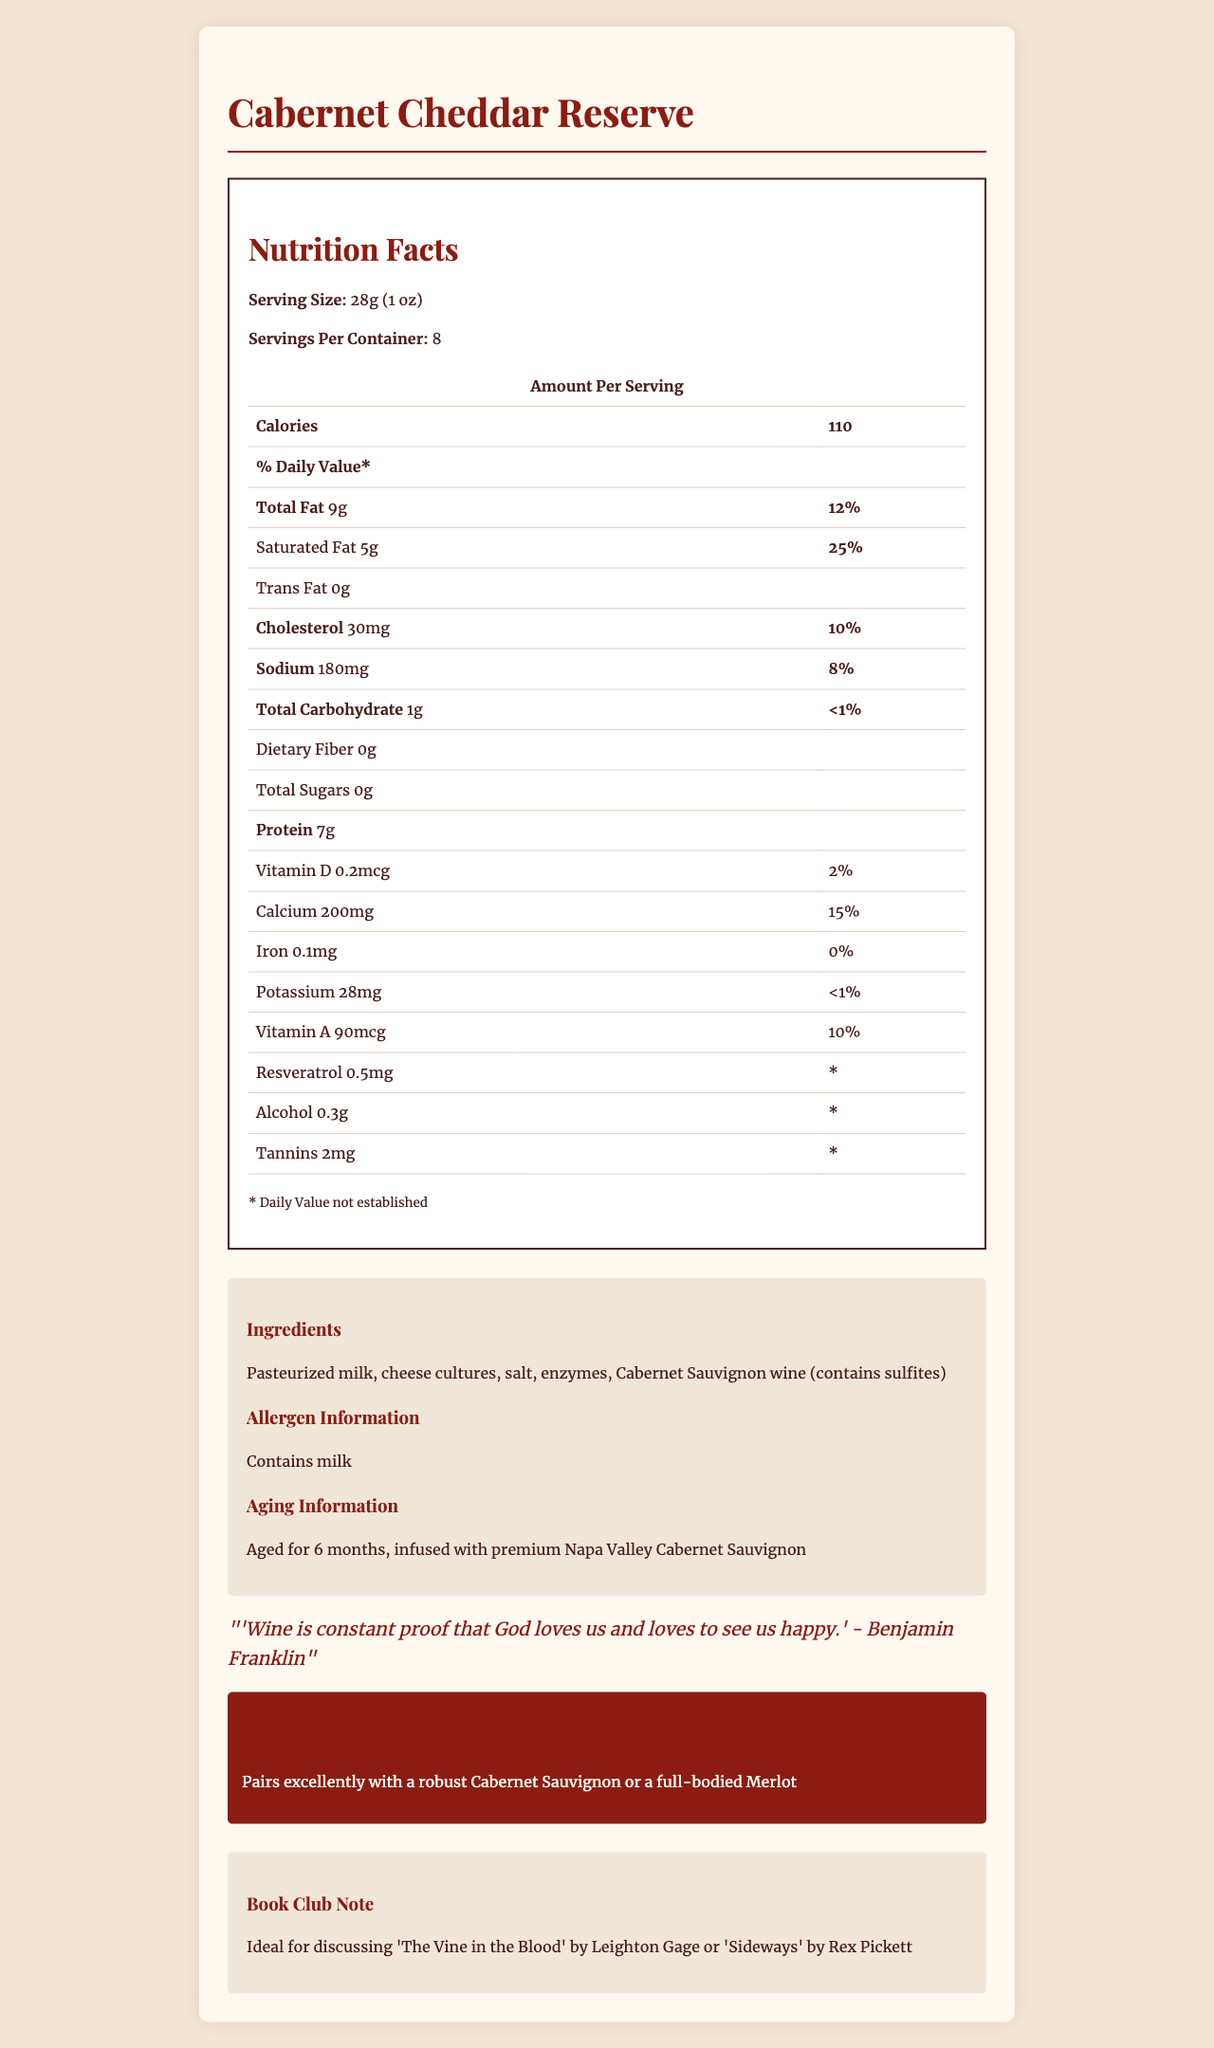what is the serving size? The serving size is explicitly mentioned at the beginning of the Nutrition Facts section.
Answer: 28g (1 oz) how many servings are in a container? The servings per container is listed under the serving size.
Answer: 8 how many calories are in one serving? The amount of calories per serving is given directly in the nutrition facts table.
Answer: 110 what is the percentage of daily value for total fat? The daily value percentage for total fat is listed beside the amount of total fat.
Answer: 12% how much protein is in one serving? The amount of protein per serving is provided in the nutrition facts section.
Answer: 7g does this product contain any trans fat? Trans fat amount is listed as 0g.
Answer: No what is the cholesterol content? A. 15mg B. 20mg C. 30mg D. 40mg The document specifies the cholesterol content as 30mg.
Answer: C which vitamin has the highest daily value percentage? A. Vitamin A B. Vitamin D C. Iron D. Calcium The daily value percentages are listed, and Calcium has the highest at 15%.
Answer: D does the cheese contain any dietary fiber? The dietary fiber amount is listed as 0g.
Answer: No define the cheese's unique nutritional profile and any special ingredients or features it has The document highlights both nutritional values and special features like wine infusion and aging process.
Answer: The Cabernet Cheddar Reserve is infused with Cabernet Sauvignon wine and contains 110 calories per serving, with 9g of total fat and 7g of protein. It has notable amounts of saturated fat (5g, 25% DV) and cholesterol (30mg, 10% DV). The cheese also includes unique components like resveratrol, small amounts of alcohol (0.3g), and tannins. It is aged for 6 months with Napa Valley Cabernet Sauvignon and pairs well with robust red wines. how much sodium is in one serving? The sodium content per serving is listed in the document.
Answer: 180mg what are the main ingredients of this cheese? The ingredients are listed in the relevant section of the document.
Answer: Pasteurized milk, cheese cultures, salt, enzymes, Cabernet Sauvignon wine (contains sulfites) can the nutrition label determine the taste of the cheese? The nutrition label provides various nutritional information but doesn't describe the taste profile of the cheese.
Answer: Not enough information how much calcium does one serving provide? The calcium content per serving is detailed in both milligrams and daily percentage value.
Answer: 200mg, 15% DV how much alcohol content does this cheese have? The document specifies the amount of alcohol content per serving.
Answer: 0.3g what quote is mentioned in the document? The literary quote by Benjamin Franklin is included in the document.
Answer: "Wine is constant proof that God loves us and loves to see us happy." - Benjamin Franklin which book is suggested for discussion with this cheese? The book club note suggests these two books for discussion.
Answer: 'The Vine in the Blood' by Leighton Gage or 'Sideways' by Rex Pickett 